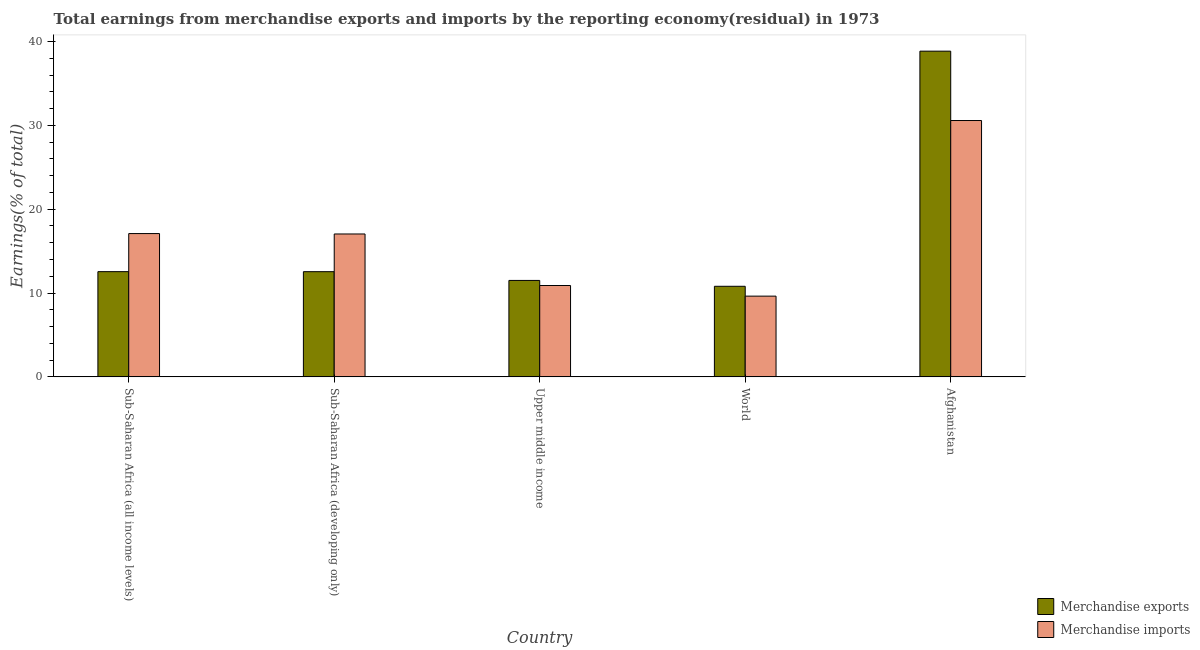How many groups of bars are there?
Your answer should be very brief. 5. Are the number of bars per tick equal to the number of legend labels?
Your answer should be compact. Yes. How many bars are there on the 3rd tick from the left?
Make the answer very short. 2. How many bars are there on the 5th tick from the right?
Your answer should be compact. 2. What is the label of the 1st group of bars from the left?
Make the answer very short. Sub-Saharan Africa (all income levels). In how many cases, is the number of bars for a given country not equal to the number of legend labels?
Provide a short and direct response. 0. What is the earnings from merchandise imports in Afghanistan?
Your answer should be very brief. 30.57. Across all countries, what is the maximum earnings from merchandise exports?
Provide a short and direct response. 38.84. Across all countries, what is the minimum earnings from merchandise exports?
Provide a short and direct response. 10.8. In which country was the earnings from merchandise exports maximum?
Offer a very short reply. Afghanistan. In which country was the earnings from merchandise exports minimum?
Provide a short and direct response. World. What is the total earnings from merchandise exports in the graph?
Your answer should be very brief. 86.24. What is the difference between the earnings from merchandise imports in Afghanistan and that in Upper middle income?
Provide a short and direct response. 19.68. What is the difference between the earnings from merchandise imports in Afghanistan and the earnings from merchandise exports in Sub-Saharan Africa (all income levels)?
Your answer should be very brief. 18.02. What is the average earnings from merchandise imports per country?
Your answer should be very brief. 17.05. What is the difference between the earnings from merchandise imports and earnings from merchandise exports in Afghanistan?
Your answer should be compact. -8.27. In how many countries, is the earnings from merchandise imports greater than 14 %?
Your answer should be compact. 3. What is the ratio of the earnings from merchandise imports in Sub-Saharan Africa (developing only) to that in Upper middle income?
Ensure brevity in your answer.  1.56. What is the difference between the highest and the second highest earnings from merchandise exports?
Keep it short and to the point. 26.3. What is the difference between the highest and the lowest earnings from merchandise imports?
Your response must be concise. 20.94. In how many countries, is the earnings from merchandise exports greater than the average earnings from merchandise exports taken over all countries?
Give a very brief answer. 1. Is the sum of the earnings from merchandise imports in Sub-Saharan Africa (developing only) and World greater than the maximum earnings from merchandise exports across all countries?
Offer a very short reply. No. What does the 1st bar from the right in Sub-Saharan Africa (developing only) represents?
Your response must be concise. Merchandise imports. How many bars are there?
Provide a succinct answer. 10. Are all the bars in the graph horizontal?
Keep it short and to the point. No. How many countries are there in the graph?
Offer a very short reply. 5. What is the difference between two consecutive major ticks on the Y-axis?
Offer a very short reply. 10. Are the values on the major ticks of Y-axis written in scientific E-notation?
Your answer should be compact. No. Does the graph contain any zero values?
Your answer should be very brief. No. How many legend labels are there?
Offer a very short reply. 2. How are the legend labels stacked?
Provide a succinct answer. Vertical. What is the title of the graph?
Provide a succinct answer. Total earnings from merchandise exports and imports by the reporting economy(residual) in 1973. Does "Research and Development" appear as one of the legend labels in the graph?
Your response must be concise. No. What is the label or title of the X-axis?
Provide a succinct answer. Country. What is the label or title of the Y-axis?
Provide a succinct answer. Earnings(% of total). What is the Earnings(% of total) in Merchandise exports in Sub-Saharan Africa (all income levels)?
Provide a succinct answer. 12.55. What is the Earnings(% of total) in Merchandise imports in Sub-Saharan Africa (all income levels)?
Offer a terse response. 17.09. What is the Earnings(% of total) in Merchandise exports in Sub-Saharan Africa (developing only)?
Make the answer very short. 12.54. What is the Earnings(% of total) of Merchandise imports in Sub-Saharan Africa (developing only)?
Offer a very short reply. 17.04. What is the Earnings(% of total) of Merchandise exports in Upper middle income?
Your answer should be very brief. 11.5. What is the Earnings(% of total) in Merchandise imports in Upper middle income?
Make the answer very short. 10.9. What is the Earnings(% of total) of Merchandise exports in World?
Keep it short and to the point. 10.8. What is the Earnings(% of total) in Merchandise imports in World?
Ensure brevity in your answer.  9.63. What is the Earnings(% of total) of Merchandise exports in Afghanistan?
Your answer should be compact. 38.84. What is the Earnings(% of total) of Merchandise imports in Afghanistan?
Your answer should be very brief. 30.57. Across all countries, what is the maximum Earnings(% of total) in Merchandise exports?
Provide a succinct answer. 38.84. Across all countries, what is the maximum Earnings(% of total) of Merchandise imports?
Your answer should be very brief. 30.57. Across all countries, what is the minimum Earnings(% of total) in Merchandise exports?
Make the answer very short. 10.8. Across all countries, what is the minimum Earnings(% of total) of Merchandise imports?
Offer a terse response. 9.63. What is the total Earnings(% of total) of Merchandise exports in the graph?
Offer a very short reply. 86.24. What is the total Earnings(% of total) in Merchandise imports in the graph?
Keep it short and to the point. 85.23. What is the difference between the Earnings(% of total) of Merchandise exports in Sub-Saharan Africa (all income levels) and that in Sub-Saharan Africa (developing only)?
Provide a succinct answer. 0. What is the difference between the Earnings(% of total) of Merchandise imports in Sub-Saharan Africa (all income levels) and that in Sub-Saharan Africa (developing only)?
Give a very brief answer. 0.05. What is the difference between the Earnings(% of total) of Merchandise exports in Sub-Saharan Africa (all income levels) and that in Upper middle income?
Your response must be concise. 1.05. What is the difference between the Earnings(% of total) of Merchandise imports in Sub-Saharan Africa (all income levels) and that in Upper middle income?
Ensure brevity in your answer.  6.19. What is the difference between the Earnings(% of total) in Merchandise exports in Sub-Saharan Africa (all income levels) and that in World?
Your response must be concise. 1.75. What is the difference between the Earnings(% of total) of Merchandise imports in Sub-Saharan Africa (all income levels) and that in World?
Ensure brevity in your answer.  7.46. What is the difference between the Earnings(% of total) in Merchandise exports in Sub-Saharan Africa (all income levels) and that in Afghanistan?
Offer a terse response. -26.3. What is the difference between the Earnings(% of total) of Merchandise imports in Sub-Saharan Africa (all income levels) and that in Afghanistan?
Ensure brevity in your answer.  -13.48. What is the difference between the Earnings(% of total) of Merchandise exports in Sub-Saharan Africa (developing only) and that in Upper middle income?
Offer a very short reply. 1.04. What is the difference between the Earnings(% of total) in Merchandise imports in Sub-Saharan Africa (developing only) and that in Upper middle income?
Your answer should be compact. 6.15. What is the difference between the Earnings(% of total) in Merchandise exports in Sub-Saharan Africa (developing only) and that in World?
Keep it short and to the point. 1.74. What is the difference between the Earnings(% of total) in Merchandise imports in Sub-Saharan Africa (developing only) and that in World?
Your answer should be very brief. 7.41. What is the difference between the Earnings(% of total) in Merchandise exports in Sub-Saharan Africa (developing only) and that in Afghanistan?
Keep it short and to the point. -26.3. What is the difference between the Earnings(% of total) of Merchandise imports in Sub-Saharan Africa (developing only) and that in Afghanistan?
Your response must be concise. -13.53. What is the difference between the Earnings(% of total) in Merchandise exports in Upper middle income and that in World?
Give a very brief answer. 0.7. What is the difference between the Earnings(% of total) in Merchandise imports in Upper middle income and that in World?
Your answer should be very brief. 1.27. What is the difference between the Earnings(% of total) in Merchandise exports in Upper middle income and that in Afghanistan?
Make the answer very short. -27.34. What is the difference between the Earnings(% of total) in Merchandise imports in Upper middle income and that in Afghanistan?
Make the answer very short. -19.68. What is the difference between the Earnings(% of total) in Merchandise exports in World and that in Afghanistan?
Your answer should be compact. -28.04. What is the difference between the Earnings(% of total) of Merchandise imports in World and that in Afghanistan?
Your answer should be very brief. -20.94. What is the difference between the Earnings(% of total) in Merchandise exports in Sub-Saharan Africa (all income levels) and the Earnings(% of total) in Merchandise imports in Sub-Saharan Africa (developing only)?
Give a very brief answer. -4.49. What is the difference between the Earnings(% of total) of Merchandise exports in Sub-Saharan Africa (all income levels) and the Earnings(% of total) of Merchandise imports in Upper middle income?
Offer a terse response. 1.65. What is the difference between the Earnings(% of total) in Merchandise exports in Sub-Saharan Africa (all income levels) and the Earnings(% of total) in Merchandise imports in World?
Provide a succinct answer. 2.92. What is the difference between the Earnings(% of total) of Merchandise exports in Sub-Saharan Africa (all income levels) and the Earnings(% of total) of Merchandise imports in Afghanistan?
Provide a succinct answer. -18.02. What is the difference between the Earnings(% of total) of Merchandise exports in Sub-Saharan Africa (developing only) and the Earnings(% of total) of Merchandise imports in Upper middle income?
Provide a short and direct response. 1.65. What is the difference between the Earnings(% of total) in Merchandise exports in Sub-Saharan Africa (developing only) and the Earnings(% of total) in Merchandise imports in World?
Your response must be concise. 2.92. What is the difference between the Earnings(% of total) in Merchandise exports in Sub-Saharan Africa (developing only) and the Earnings(% of total) in Merchandise imports in Afghanistan?
Offer a very short reply. -18.03. What is the difference between the Earnings(% of total) of Merchandise exports in Upper middle income and the Earnings(% of total) of Merchandise imports in World?
Ensure brevity in your answer.  1.87. What is the difference between the Earnings(% of total) in Merchandise exports in Upper middle income and the Earnings(% of total) in Merchandise imports in Afghanistan?
Offer a terse response. -19.07. What is the difference between the Earnings(% of total) in Merchandise exports in World and the Earnings(% of total) in Merchandise imports in Afghanistan?
Ensure brevity in your answer.  -19.77. What is the average Earnings(% of total) in Merchandise exports per country?
Keep it short and to the point. 17.25. What is the average Earnings(% of total) in Merchandise imports per country?
Provide a short and direct response. 17.05. What is the difference between the Earnings(% of total) of Merchandise exports and Earnings(% of total) of Merchandise imports in Sub-Saharan Africa (all income levels)?
Offer a very short reply. -4.54. What is the difference between the Earnings(% of total) of Merchandise exports and Earnings(% of total) of Merchandise imports in Sub-Saharan Africa (developing only)?
Your response must be concise. -4.5. What is the difference between the Earnings(% of total) of Merchandise exports and Earnings(% of total) of Merchandise imports in Upper middle income?
Offer a very short reply. 0.6. What is the difference between the Earnings(% of total) of Merchandise exports and Earnings(% of total) of Merchandise imports in World?
Your response must be concise. 1.17. What is the difference between the Earnings(% of total) in Merchandise exports and Earnings(% of total) in Merchandise imports in Afghanistan?
Provide a short and direct response. 8.27. What is the ratio of the Earnings(% of total) in Merchandise imports in Sub-Saharan Africa (all income levels) to that in Sub-Saharan Africa (developing only)?
Your answer should be compact. 1. What is the ratio of the Earnings(% of total) in Merchandise exports in Sub-Saharan Africa (all income levels) to that in Upper middle income?
Your answer should be very brief. 1.09. What is the ratio of the Earnings(% of total) in Merchandise imports in Sub-Saharan Africa (all income levels) to that in Upper middle income?
Ensure brevity in your answer.  1.57. What is the ratio of the Earnings(% of total) of Merchandise exports in Sub-Saharan Africa (all income levels) to that in World?
Ensure brevity in your answer.  1.16. What is the ratio of the Earnings(% of total) of Merchandise imports in Sub-Saharan Africa (all income levels) to that in World?
Give a very brief answer. 1.77. What is the ratio of the Earnings(% of total) of Merchandise exports in Sub-Saharan Africa (all income levels) to that in Afghanistan?
Ensure brevity in your answer.  0.32. What is the ratio of the Earnings(% of total) in Merchandise imports in Sub-Saharan Africa (all income levels) to that in Afghanistan?
Your answer should be very brief. 0.56. What is the ratio of the Earnings(% of total) in Merchandise exports in Sub-Saharan Africa (developing only) to that in Upper middle income?
Your response must be concise. 1.09. What is the ratio of the Earnings(% of total) of Merchandise imports in Sub-Saharan Africa (developing only) to that in Upper middle income?
Provide a short and direct response. 1.56. What is the ratio of the Earnings(% of total) in Merchandise exports in Sub-Saharan Africa (developing only) to that in World?
Provide a short and direct response. 1.16. What is the ratio of the Earnings(% of total) of Merchandise imports in Sub-Saharan Africa (developing only) to that in World?
Give a very brief answer. 1.77. What is the ratio of the Earnings(% of total) in Merchandise exports in Sub-Saharan Africa (developing only) to that in Afghanistan?
Your answer should be compact. 0.32. What is the ratio of the Earnings(% of total) of Merchandise imports in Sub-Saharan Africa (developing only) to that in Afghanistan?
Offer a very short reply. 0.56. What is the ratio of the Earnings(% of total) of Merchandise exports in Upper middle income to that in World?
Provide a short and direct response. 1.06. What is the ratio of the Earnings(% of total) in Merchandise imports in Upper middle income to that in World?
Offer a very short reply. 1.13. What is the ratio of the Earnings(% of total) in Merchandise exports in Upper middle income to that in Afghanistan?
Offer a terse response. 0.3. What is the ratio of the Earnings(% of total) in Merchandise imports in Upper middle income to that in Afghanistan?
Provide a short and direct response. 0.36. What is the ratio of the Earnings(% of total) of Merchandise exports in World to that in Afghanistan?
Provide a succinct answer. 0.28. What is the ratio of the Earnings(% of total) in Merchandise imports in World to that in Afghanistan?
Give a very brief answer. 0.32. What is the difference between the highest and the second highest Earnings(% of total) in Merchandise exports?
Ensure brevity in your answer.  26.3. What is the difference between the highest and the second highest Earnings(% of total) in Merchandise imports?
Ensure brevity in your answer.  13.48. What is the difference between the highest and the lowest Earnings(% of total) in Merchandise exports?
Provide a succinct answer. 28.04. What is the difference between the highest and the lowest Earnings(% of total) of Merchandise imports?
Your answer should be compact. 20.94. 